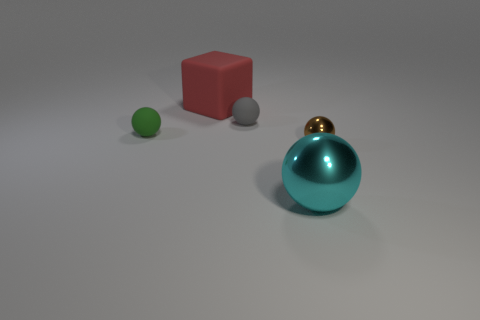Is the number of tiny brown metal balls that are on the left side of the small gray rubber object less than the number of small gray rubber balls?
Keep it short and to the point. Yes. The small thing on the left side of the tiny gray rubber sphere has what shape?
Make the answer very short. Sphere. Is the size of the cyan metallic sphere the same as the green matte sphere on the left side of the small metallic thing?
Your answer should be compact. No. Are there any large cyan balls made of the same material as the brown object?
Give a very brief answer. Yes. What number of spheres are small gray objects or green rubber objects?
Your response must be concise. 2. There is a small sphere that is on the right side of the cyan thing; is there a brown metallic ball that is behind it?
Your response must be concise. No. Is the number of green matte spheres less than the number of red rubber cylinders?
Your answer should be compact. No. How many big cyan metal objects are the same shape as the green rubber object?
Provide a succinct answer. 1. What number of brown objects are either small spheres or big blocks?
Keep it short and to the point. 1. There is a matte thing on the left side of the red matte thing that is behind the tiny gray rubber ball; what size is it?
Provide a short and direct response. Small. 